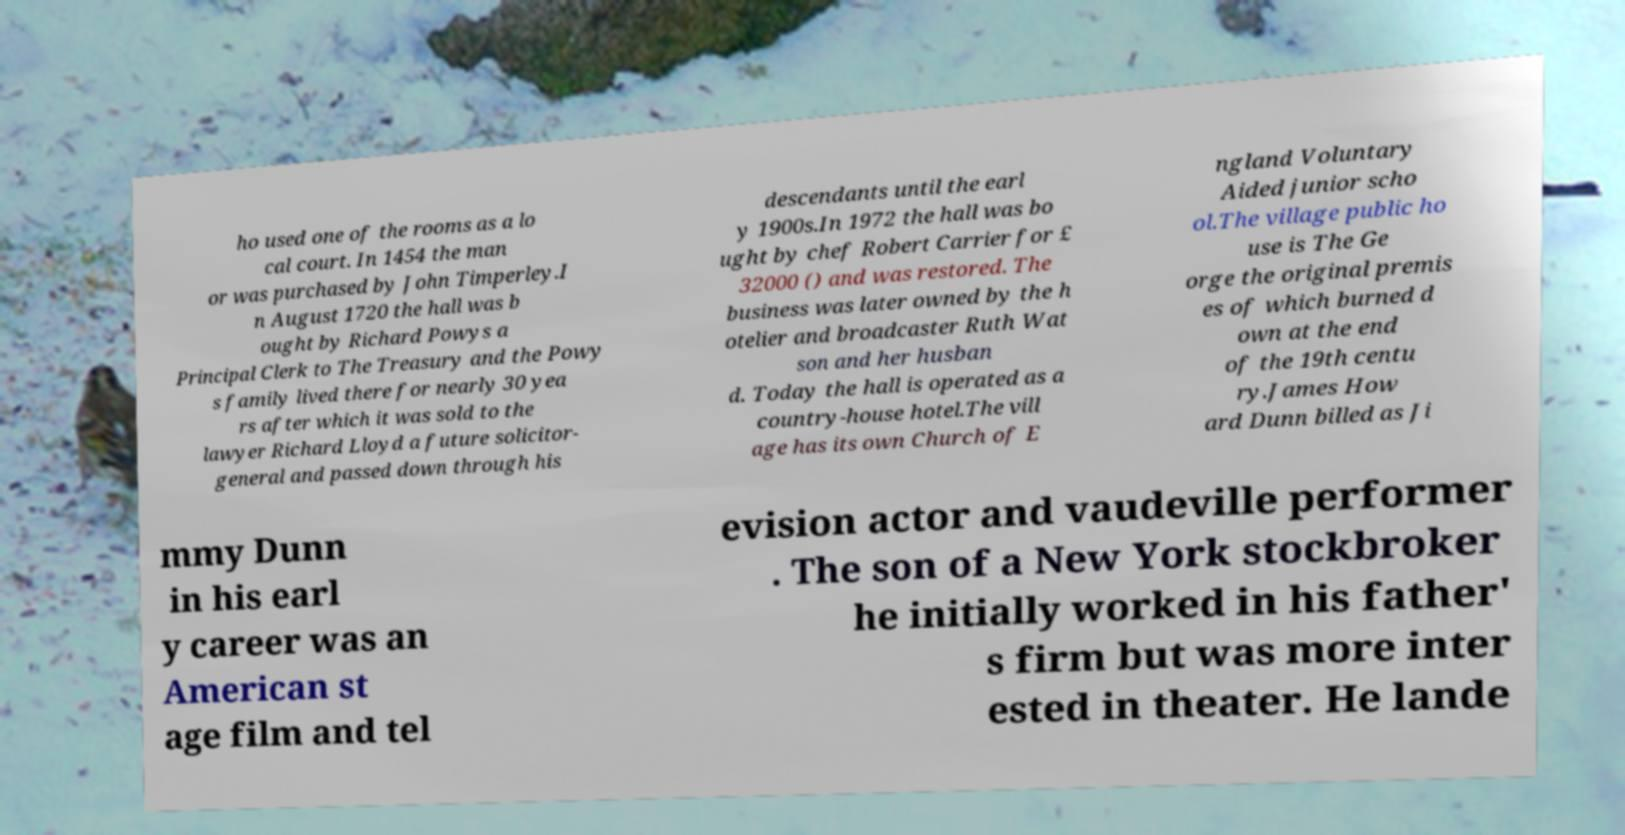Please read and relay the text visible in this image. What does it say? ho used one of the rooms as a lo cal court. In 1454 the man or was purchased by John Timperley.I n August 1720 the hall was b ought by Richard Powys a Principal Clerk to The Treasury and the Powy s family lived there for nearly 30 yea rs after which it was sold to the lawyer Richard Lloyd a future solicitor- general and passed down through his descendants until the earl y 1900s.In 1972 the hall was bo ught by chef Robert Carrier for £ 32000 () and was restored. The business was later owned by the h otelier and broadcaster Ruth Wat son and her husban d. Today the hall is operated as a country-house hotel.The vill age has its own Church of E ngland Voluntary Aided junior scho ol.The village public ho use is The Ge orge the original premis es of which burned d own at the end of the 19th centu ry.James How ard Dunn billed as Ji mmy Dunn in his earl y career was an American st age film and tel evision actor and vaudeville performer . The son of a New York stockbroker he initially worked in his father' s firm but was more inter ested in theater. He lande 